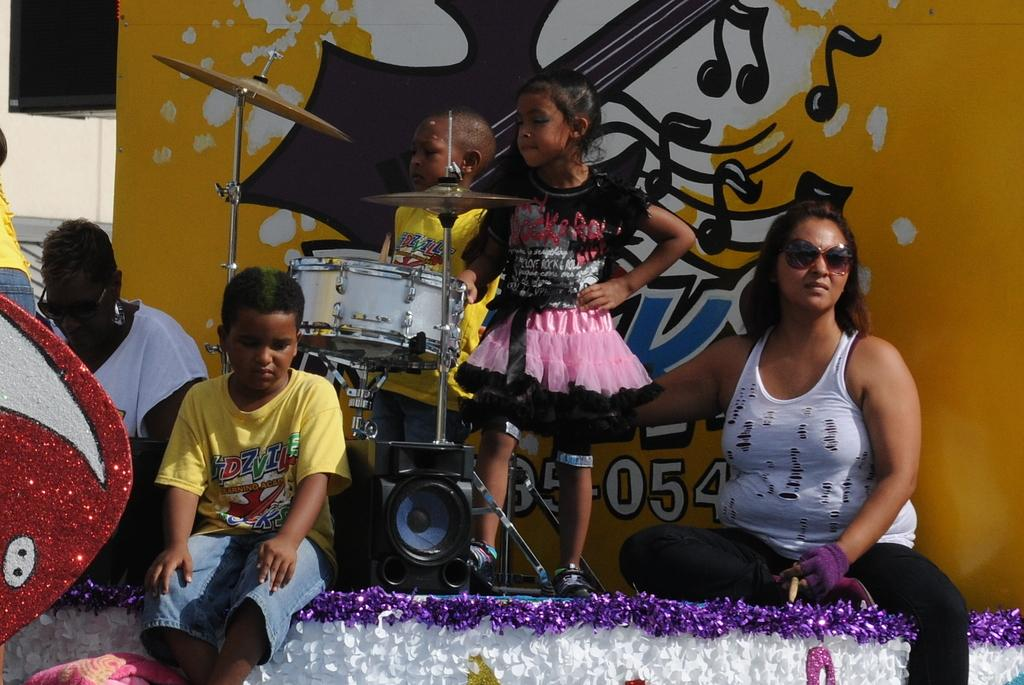How many kids are in the image? There are two kids in the image. What are the kids standing in front of? The kids are standing in front of drums. What can be seen on the stage in the image? There are people sitting on the stage in the image. What is visible behind the kids? There is a poster visible behind the kids. What type of flavor can be tasted in the seashore depicted in the image? There is no seashore depicted in the image, and therefore no flavor can be tasted. How many snails are crawling on the poster in the image? There are no snails present in the image, so it is not possible to determine how many would be on the poster. 